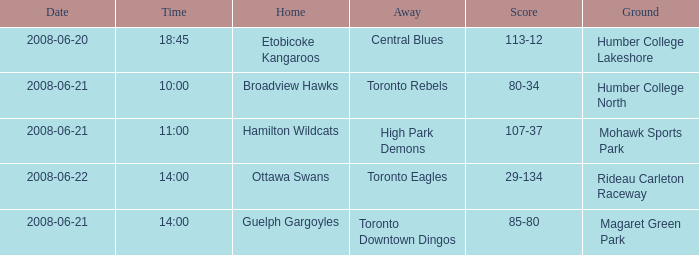What is the Away with a Ground that is humber college north? Toronto Rebels. 